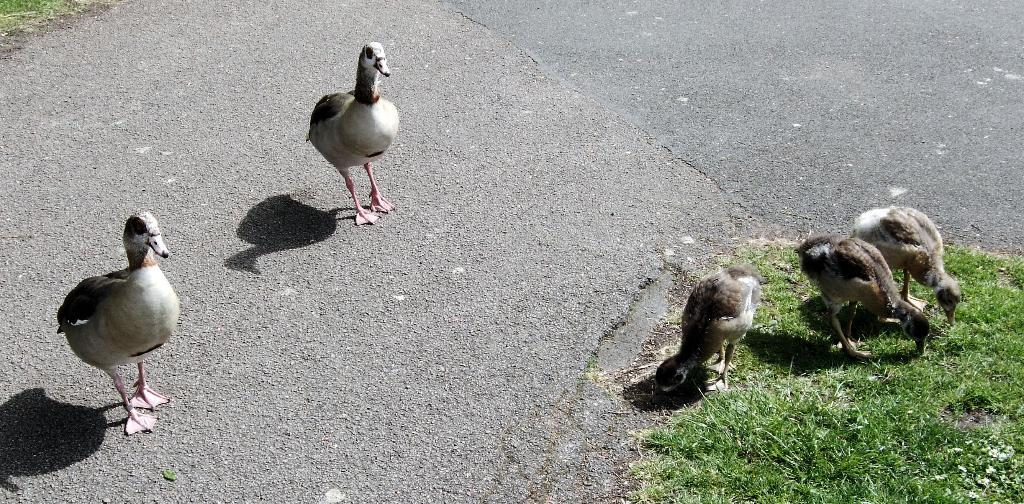What type of animals can be seen in the image? Birds can be seen in the image. What type of pathway is visible in the image? There is a road in the image. What is visible on the ground in the image? The ground is visible in the image, and there is grass on it. What type of yarn is being used by the coach during the week in the image? There is no coach, yarn, or reference to a week present in the image. 